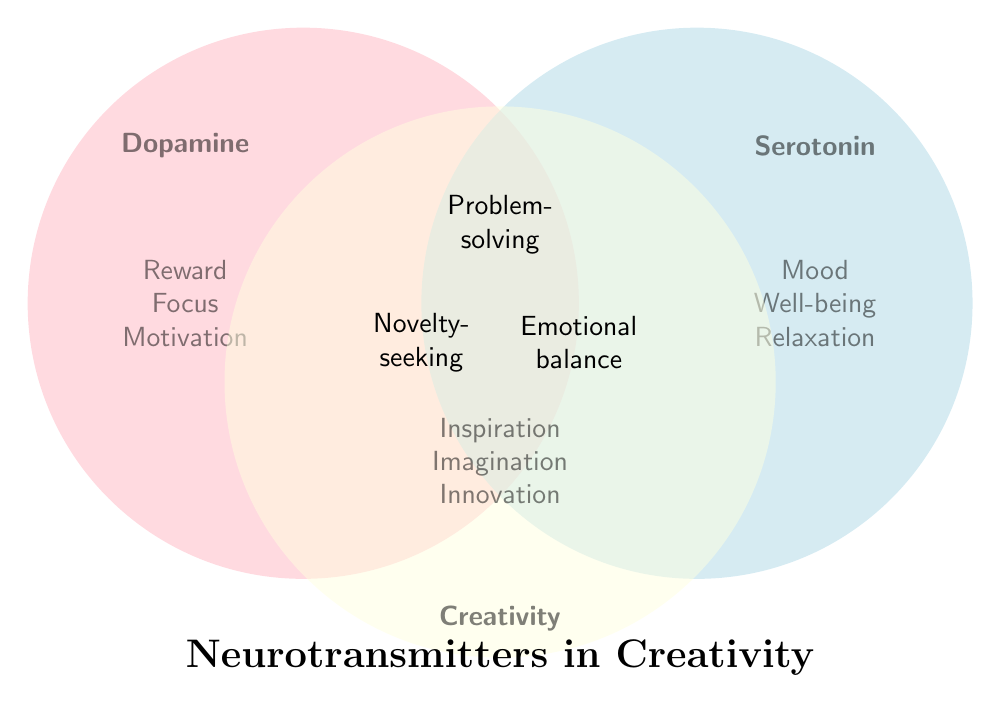What are the three main neurotransmitters involved in creativity according to the diagram? The three main neurotransmitters involved in creativity are the ones labeled in the three circles: Dopamine, Serotonin, and Creativity.
Answer: Dopamine, Serotonin, Creativity Which neurotransmitter is associated with "Reward"? By looking at the Dopamine circle, we see "Reward" listed inside it.
Answer: Dopamine Which creative process is linked with "Inspiration"? The Creativity circle contains "Inspiration" inside it.
Answer: Creativity Which neurotransmitter is linked to "Well-being"? The diagram shows "Well-being" within the Serotonin circle.
Answer: Serotonin Which neurotransmitter is associated with "Motivation" and "Focus"? Both "Motivation" and "Focus" are listed inside the Dopamine circle.
Answer: Dopamine What lies at the intersection of Dopamine and Creativity? The intersection of Dopamine and Creativity contains "Novelty-seeking."
Answer: Novelty-seeking Name an element found at the intersection of Creativity and Serotonin. At the intersection of Creativity and Serotonin, the figure lists "Emotional balance."
Answer: Emotional balance Which neurotransmitter is involved in "Sleep regulation"? "Sleep regulation" is found in the Serotonin circle.
Answer: Serotonin Is "Problem-solving" only associated with Dopamine, Serotonin, or Creativity? "Problem-solving" is listed at the intersection of Dopamine, Serotonin, and Creativity, indicating it is associated with all three.
Answer: All three Compare the elements linked to "Innovation" and "Decision-making." Which neurotransmitter(s) are they associated with? "Innovation" is in the Creativity circle, while "Decision-making" is linked to Dopamine. This means they are associated with different neurotransmitters.
Answer: Different (Creativity and Dopamine) 